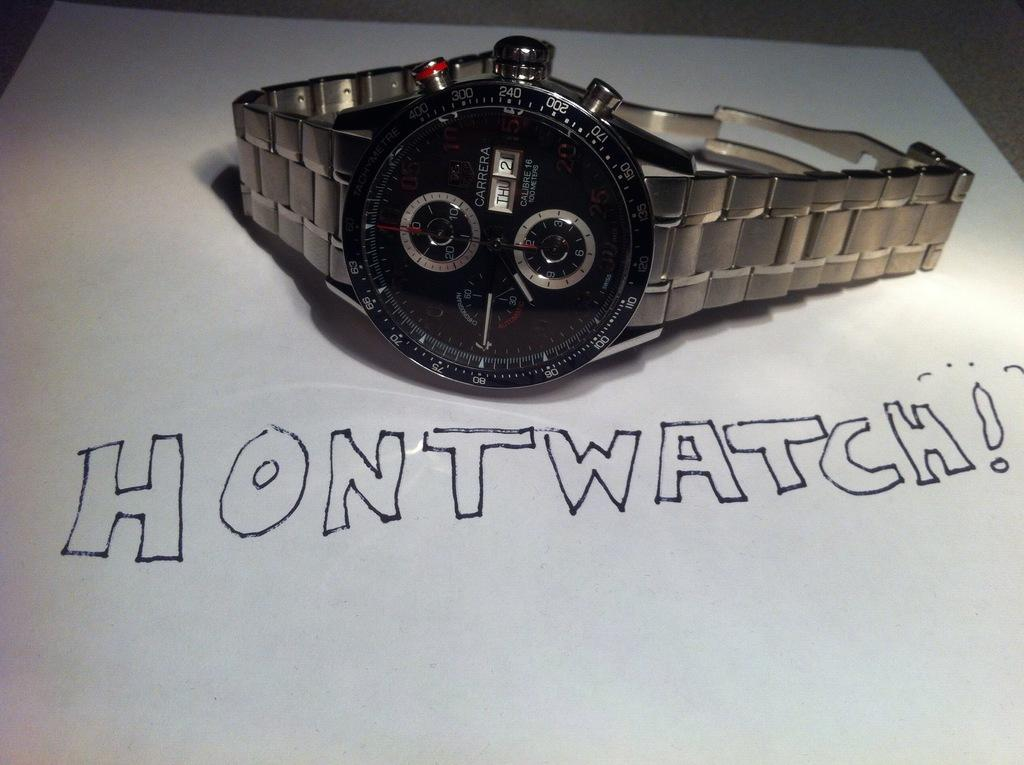<image>
Offer a succinct explanation of the picture presented. A Carrera wrist watch is sitting on a white surface that says Hontwatch! 